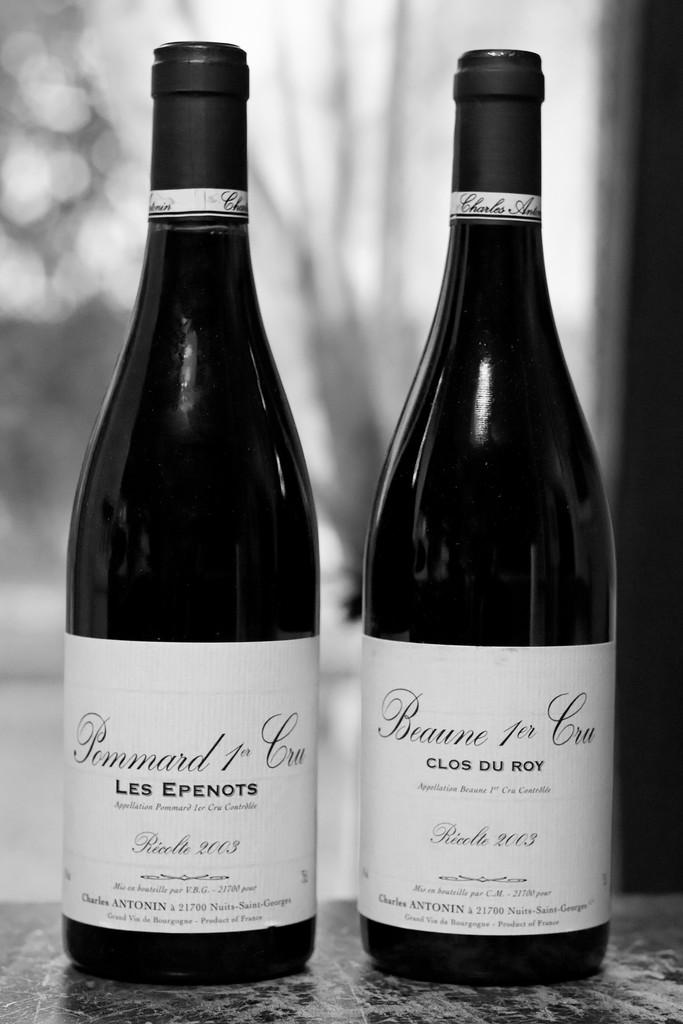<image>
Summarize the visual content of the image. Two bottles have the year 2003 printed on their labels. 